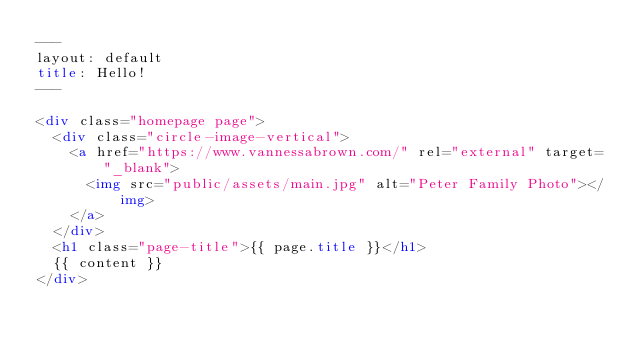<code> <loc_0><loc_0><loc_500><loc_500><_HTML_>---
layout: default
title: Hello!
---

<div class="homepage page">
  <div class="circle-image-vertical">
    <a href="https://www.vannessabrown.com/" rel="external" target="_blank">
      <img src="public/assets/main.jpg" alt="Peter Family Photo"></img>
    </a>
  </div>
  <h1 class="page-title">{{ page.title }}</h1>
  {{ content }}
</div></code> 